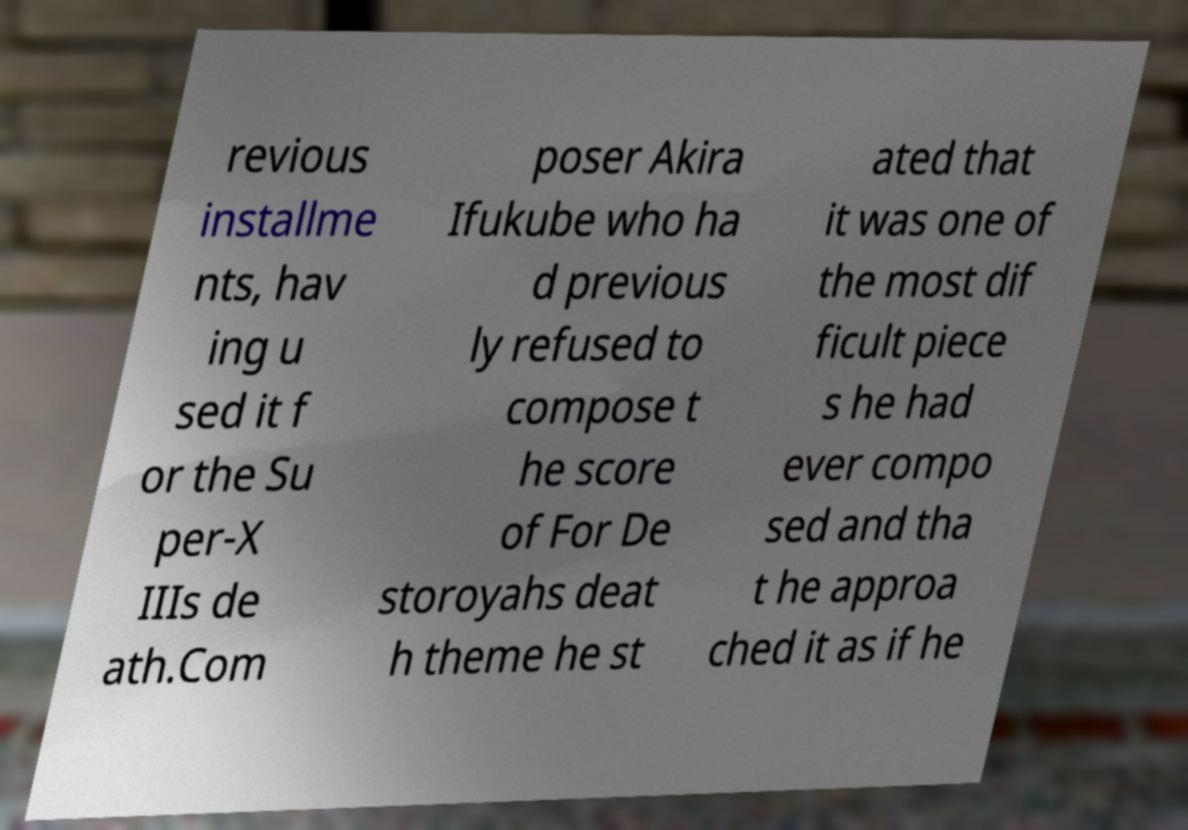Can you accurately transcribe the text from the provided image for me? revious installme nts, hav ing u sed it f or the Su per-X IIIs de ath.Com poser Akira Ifukube who ha d previous ly refused to compose t he score of For De storoyahs deat h theme he st ated that it was one of the most dif ficult piece s he had ever compo sed and tha t he approa ched it as if he 